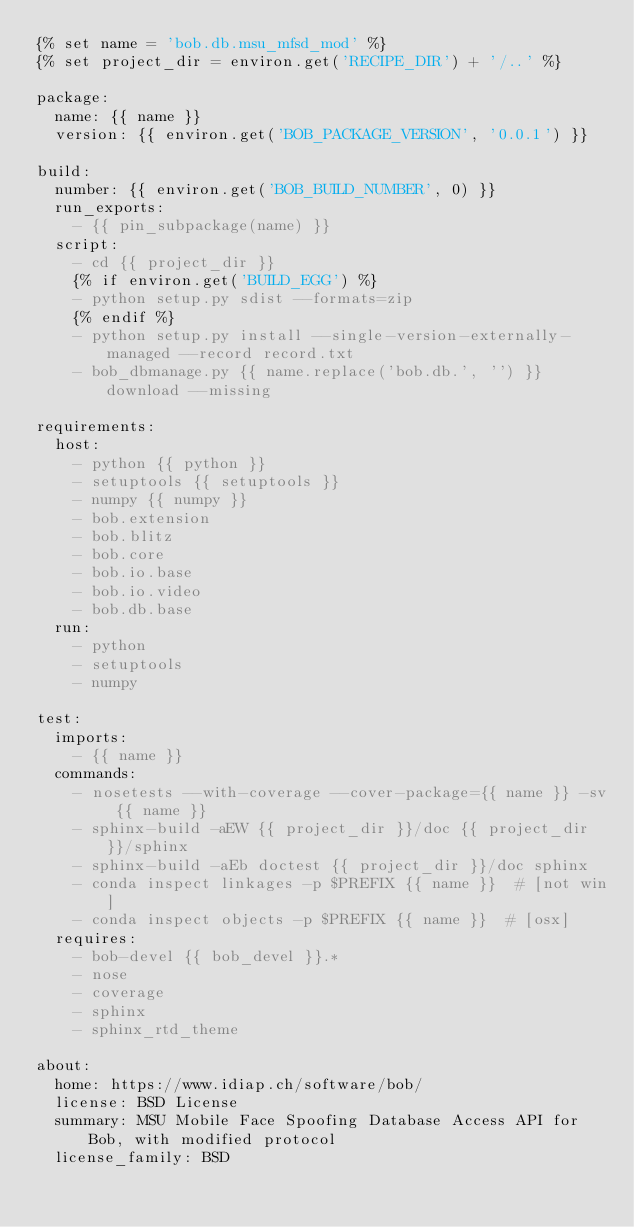<code> <loc_0><loc_0><loc_500><loc_500><_YAML_>{% set name = 'bob.db.msu_mfsd_mod' %}
{% set project_dir = environ.get('RECIPE_DIR') + '/..' %}

package:
  name: {{ name }}
  version: {{ environ.get('BOB_PACKAGE_VERSION', '0.0.1') }}

build:
  number: {{ environ.get('BOB_BUILD_NUMBER', 0) }}
  run_exports:
    - {{ pin_subpackage(name) }}
  script:
    - cd {{ project_dir }}
    {% if environ.get('BUILD_EGG') %}
    - python setup.py sdist --formats=zip
    {% endif %}
    - python setup.py install --single-version-externally-managed --record record.txt
    - bob_dbmanage.py {{ name.replace('bob.db.', '') }} download --missing

requirements:
  host:
    - python {{ python }}
    - setuptools {{ setuptools }}
    - numpy {{ numpy }}
    - bob.extension
    - bob.blitz
    - bob.core
    - bob.io.base
    - bob.io.video
    - bob.db.base
  run:
    - python
    - setuptools
    - numpy

test:
  imports:
    - {{ name }}
  commands:
    - nosetests --with-coverage --cover-package={{ name }} -sv {{ name }}
    - sphinx-build -aEW {{ project_dir }}/doc {{ project_dir }}/sphinx
    - sphinx-build -aEb doctest {{ project_dir }}/doc sphinx
    - conda inspect linkages -p $PREFIX {{ name }}  # [not win]
    - conda inspect objects -p $PREFIX {{ name }}  # [osx]
  requires:
    - bob-devel {{ bob_devel }}.*
    - nose
    - coverage
    - sphinx
    - sphinx_rtd_theme

about:
  home: https://www.idiap.ch/software/bob/
  license: BSD License
  summary: MSU Mobile Face Spoofing Database Access API for Bob, with modified protocol
  license_family: BSD
</code> 